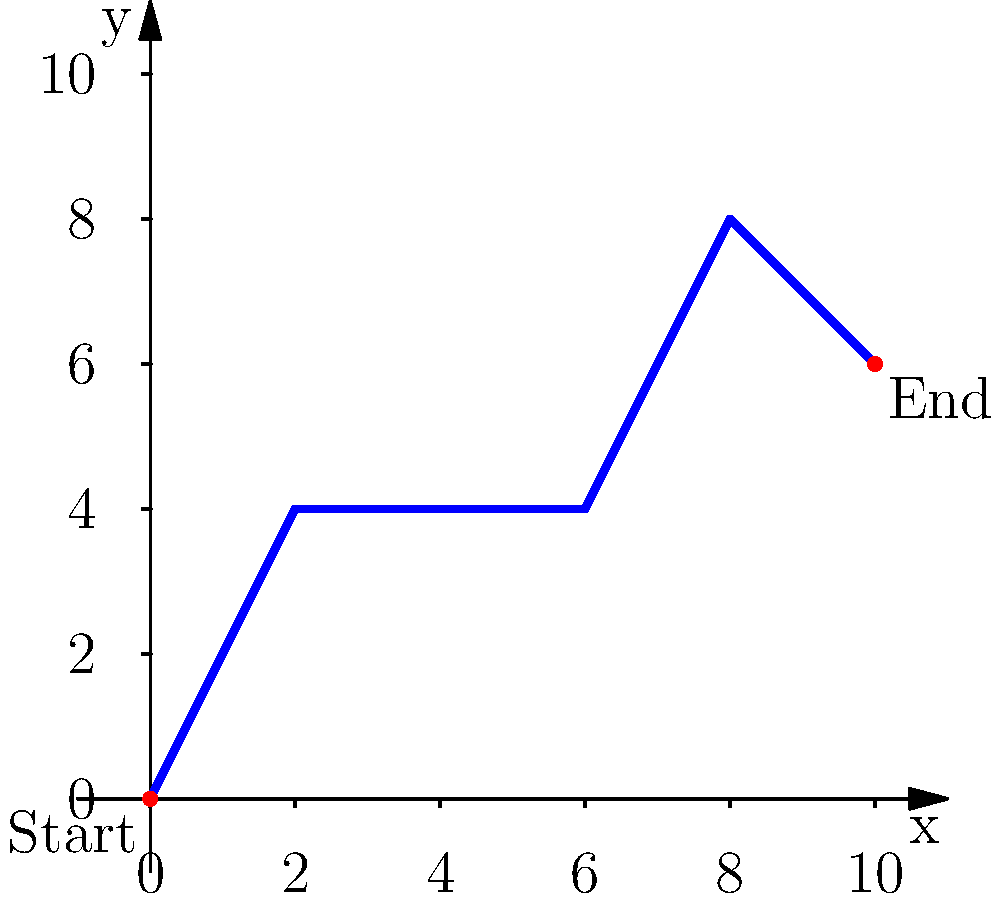A delivery truck starts its route at the origin (0, 0) and follows a path on a coordinate plane. The truck moves 2 units east and 4 units north, then 4 units east, followed by 2 units east and 4 units north, and finally 2 units east and 2 units south to reach its destination. What are the coordinates of the truck's final destination? Let's follow the truck's path step by step:

1. The truck starts at (0, 0).

2. It moves 2 units east and 4 units north:
   New position: (2, 4)

3. Then it moves 4 units east:
   New position: (6, 4)

4. Next, it moves 2 units east and 4 units north:
   New position: (8, 8)

5. Finally, it moves 2 units east and 2 units south:
   Final position: (10, 6)

To calculate the final x-coordinate:
$x = 2 + 4 + 2 + 2 = 10$

To calculate the final y-coordinate:
$y = 4 + 0 + 4 - 2 = 6$

Therefore, the truck's final destination is at the point (10, 6).
Answer: (10, 6) 